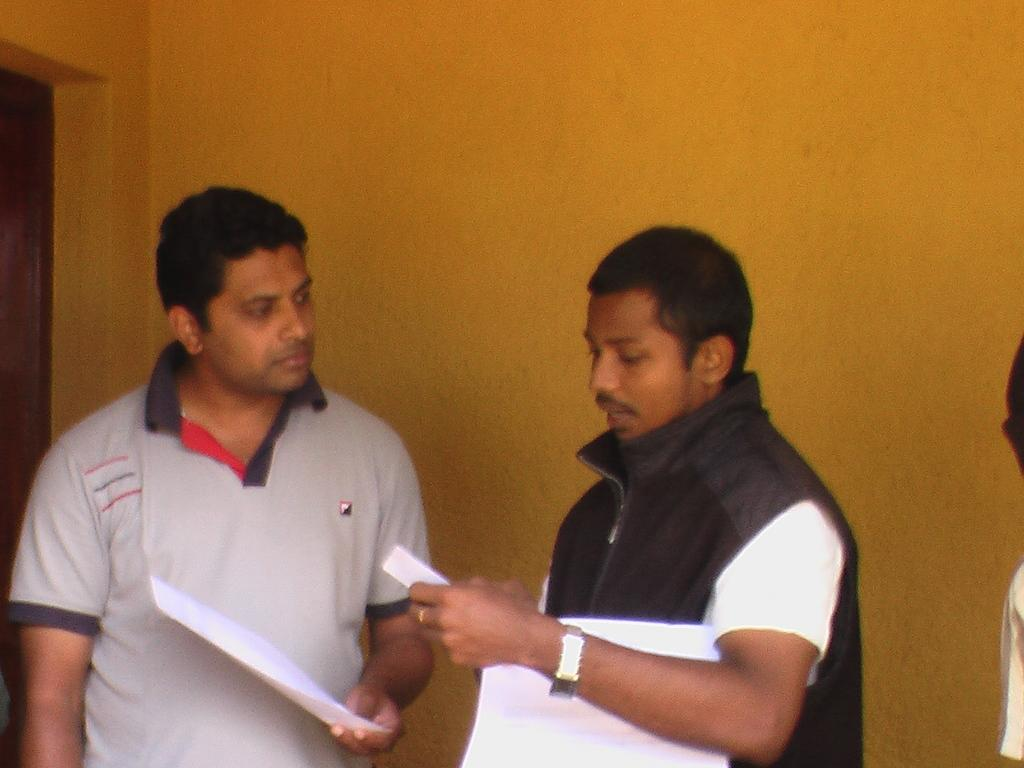How many people are present in the image? There are two people in the image. What is one of the people doing? One of the people is speaking. What are the people holding in the image? The people are holding papers. What can be seen in the background of the image? There is a wall in the background of the image. What type of division is taking place in the image? There is no division taking place in the image; it simply shows two people holding papers. Can you see a spade being used in the image? There is no spade present in the image. 